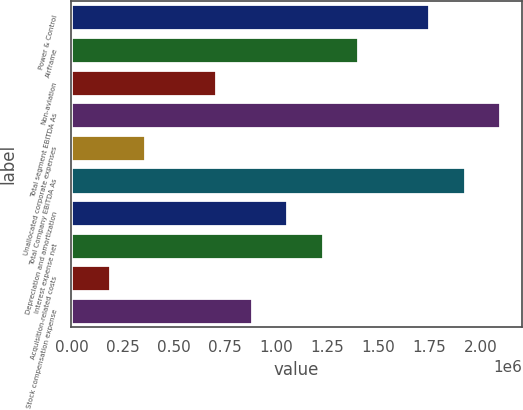Convert chart. <chart><loc_0><loc_0><loc_500><loc_500><bar_chart><fcel>Power & Control<fcel>Airframe<fcel>Non-aviation<fcel>Total segment EBITDA As<fcel>Unallocated corporate expenses<fcel>Total Company EBITDA As<fcel>Depreciation and amortization<fcel>Interest expense net<fcel>Acquisition-related costs<fcel>Stock compensation expense<nl><fcel>1.74912e+06<fcel>1.4019e+06<fcel>707446<fcel>2.09634e+06<fcel>360222<fcel>1.92273e+06<fcel>1.05467e+06<fcel>1.22828e+06<fcel>186609<fcel>881058<nl></chart> 